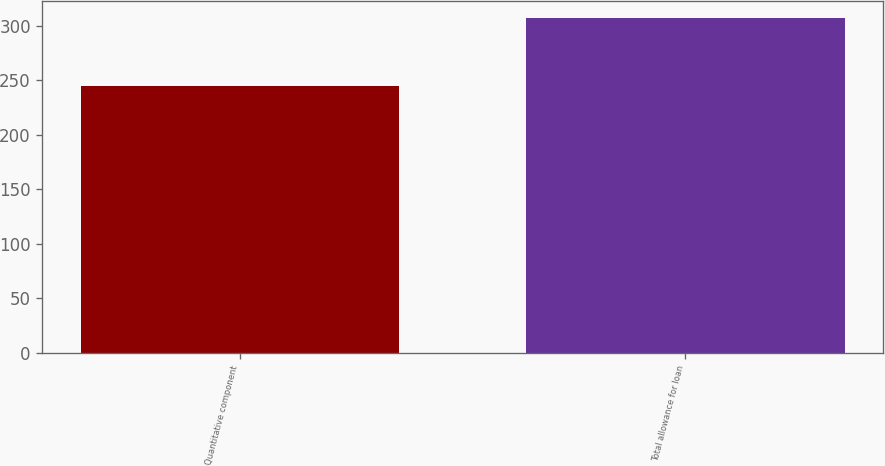<chart> <loc_0><loc_0><loc_500><loc_500><bar_chart><fcel>Quantitative component<fcel>Total allowance for loan<nl><fcel>245<fcel>307<nl></chart> 